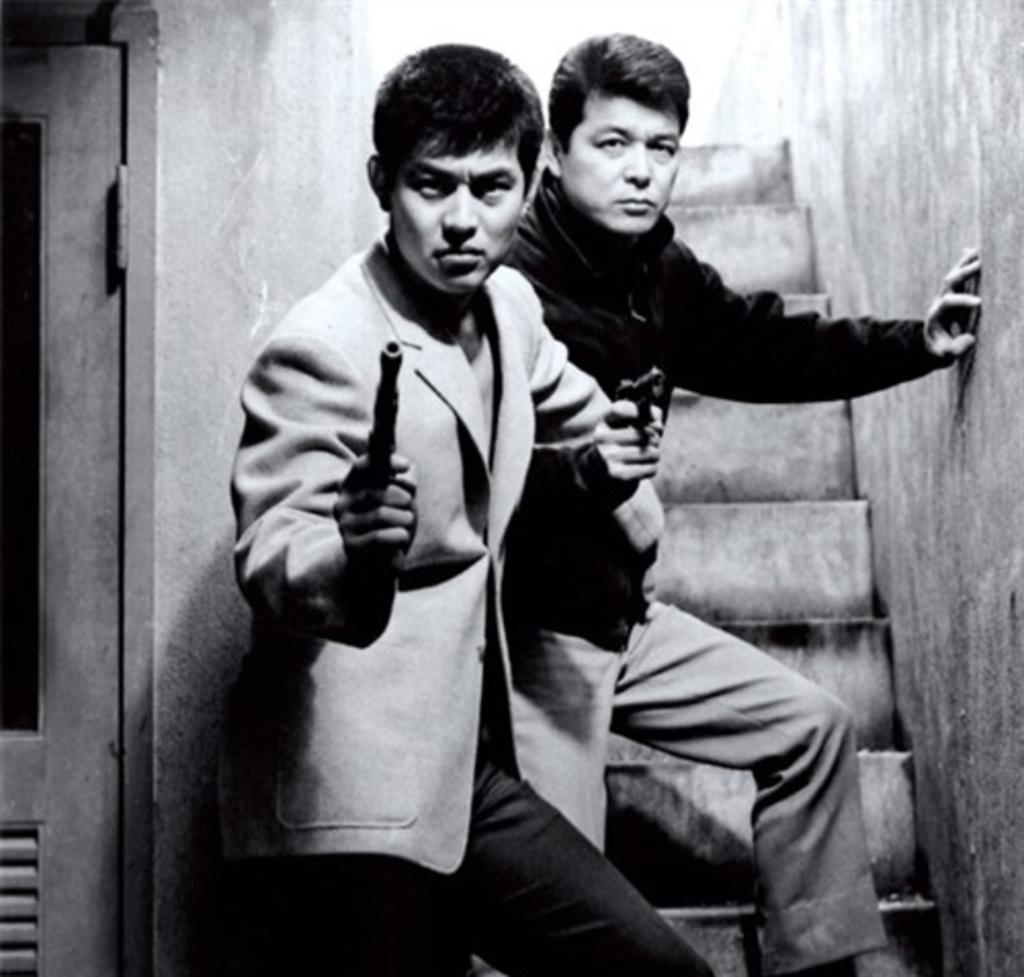In one or two sentences, can you explain what this image depicts? This is a black and white pic. We can see two men are standing on the steps and holding guns in their hands. On the left side we can see a door. 